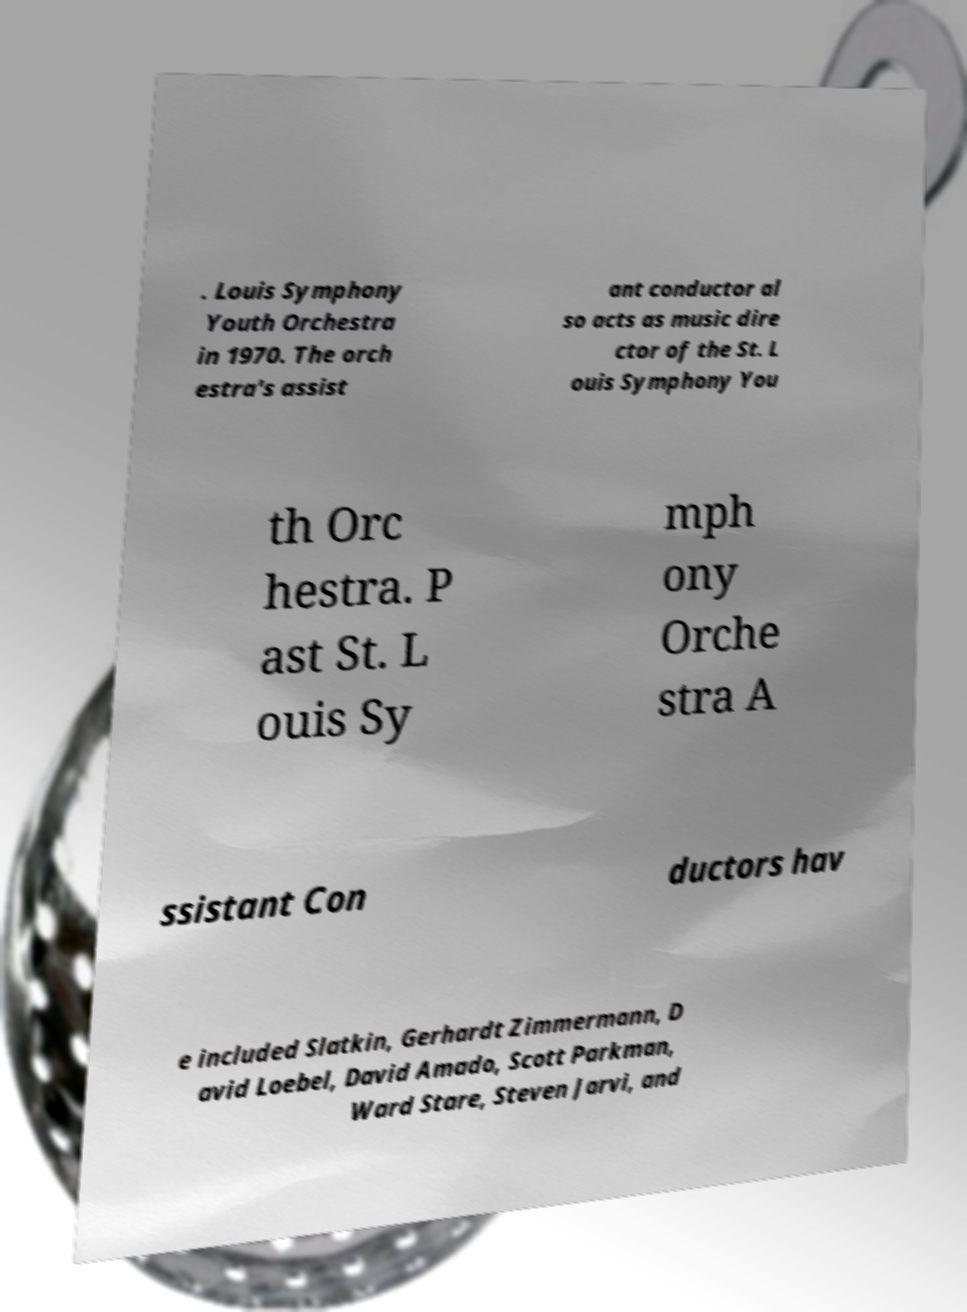What messages or text are displayed in this image? I need them in a readable, typed format. . Louis Symphony Youth Orchestra in 1970. The orch estra's assist ant conductor al so acts as music dire ctor of the St. L ouis Symphony You th Orc hestra. P ast St. L ouis Sy mph ony Orche stra A ssistant Con ductors hav e included Slatkin, Gerhardt Zimmermann, D avid Loebel, David Amado, Scott Parkman, Ward Stare, Steven Jarvi, and 